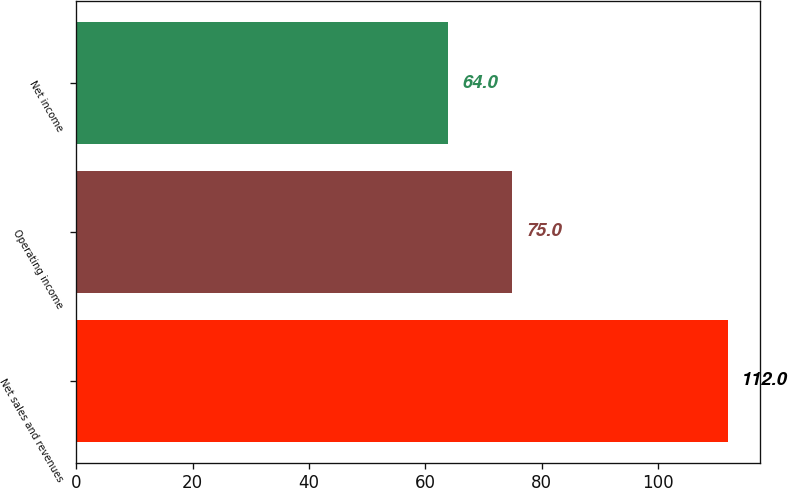<chart> <loc_0><loc_0><loc_500><loc_500><bar_chart><fcel>Net sales and revenues<fcel>Operating income<fcel>Net income<nl><fcel>112<fcel>75<fcel>64<nl></chart> 